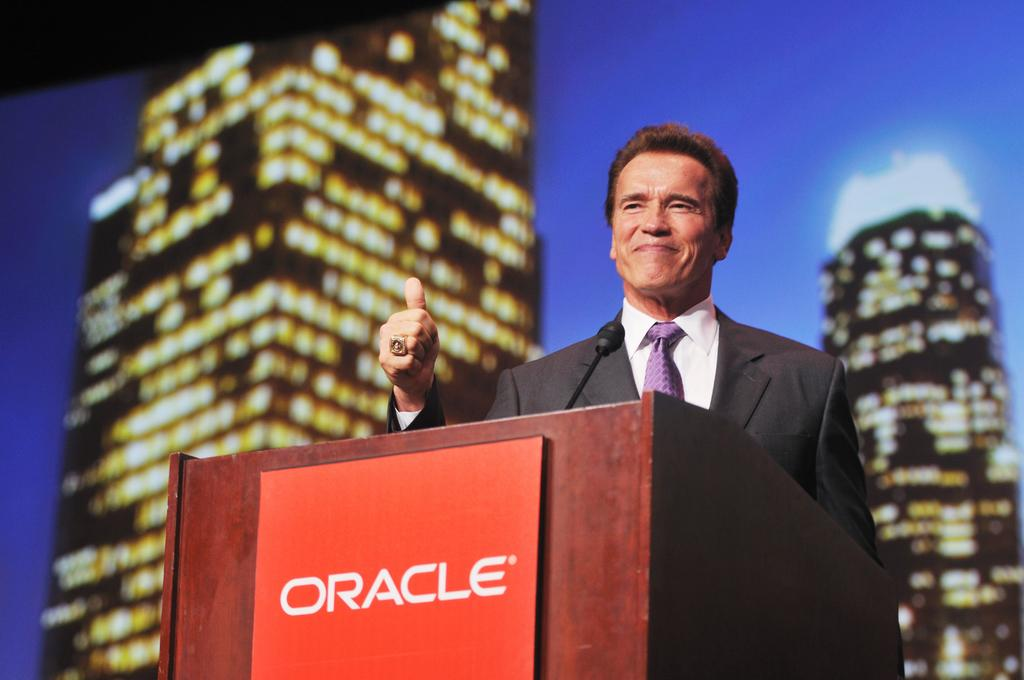What is the main subject of the image? There is a man standing in the image. What object is present near the man? There is a podium in the image. What can be seen in the distance behind the man? There are buildings in the background of the image. What is the color of the sky in the image? The sky is blue in the image. Are there any pets visible in the image? There are no pets present in the image. What type of church can be seen in the background of the image? There is no church visible in the image; only buildings are present in the background. 